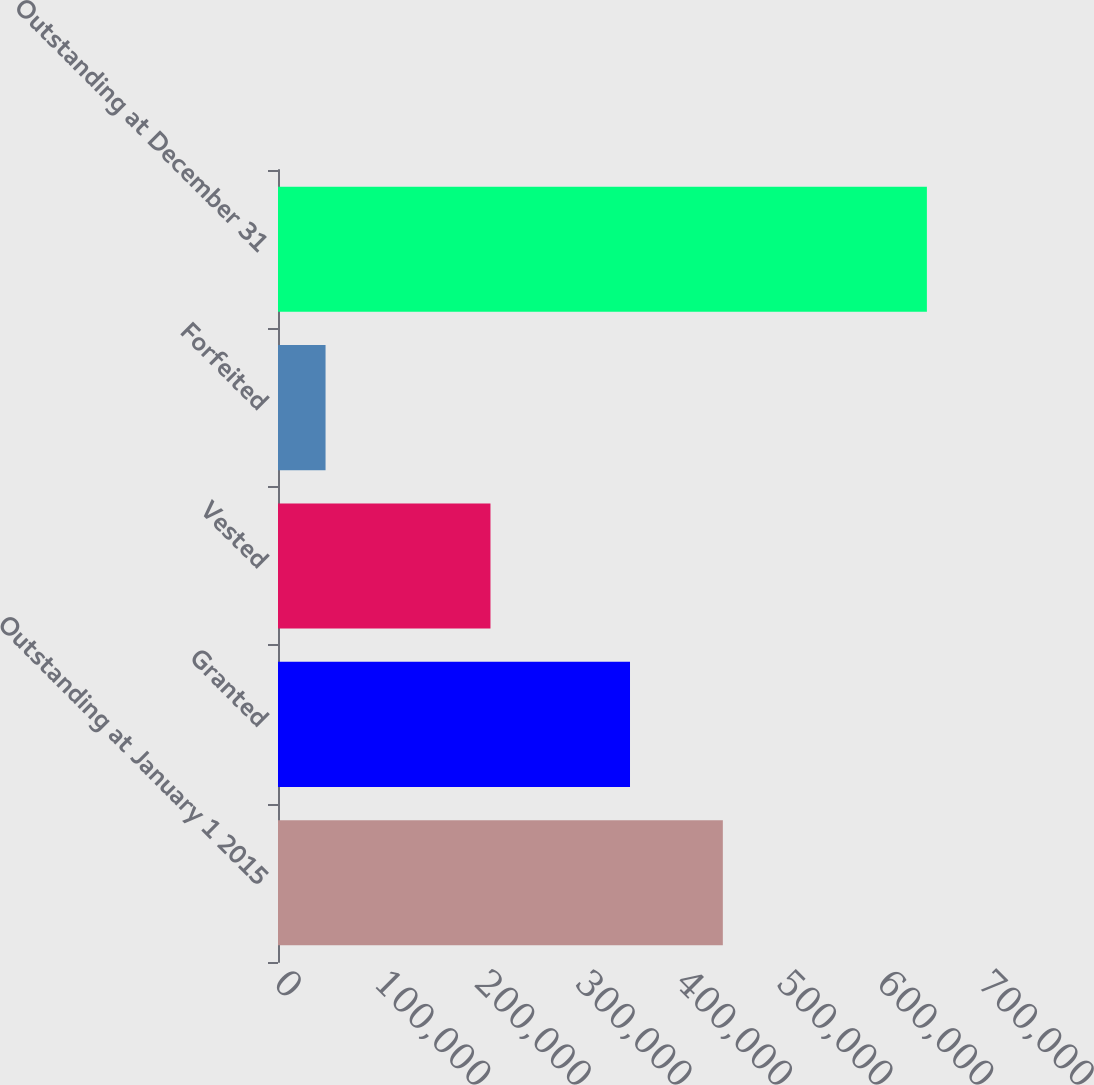<chart> <loc_0><loc_0><loc_500><loc_500><bar_chart><fcel>Outstanding at January 1 2015<fcel>Granted<fcel>Vested<fcel>Forfeited<fcel>Outstanding at December 31<nl><fcel>442310<fcel>350004<fcel>211265<fcel>47281<fcel>645205<nl></chart> 